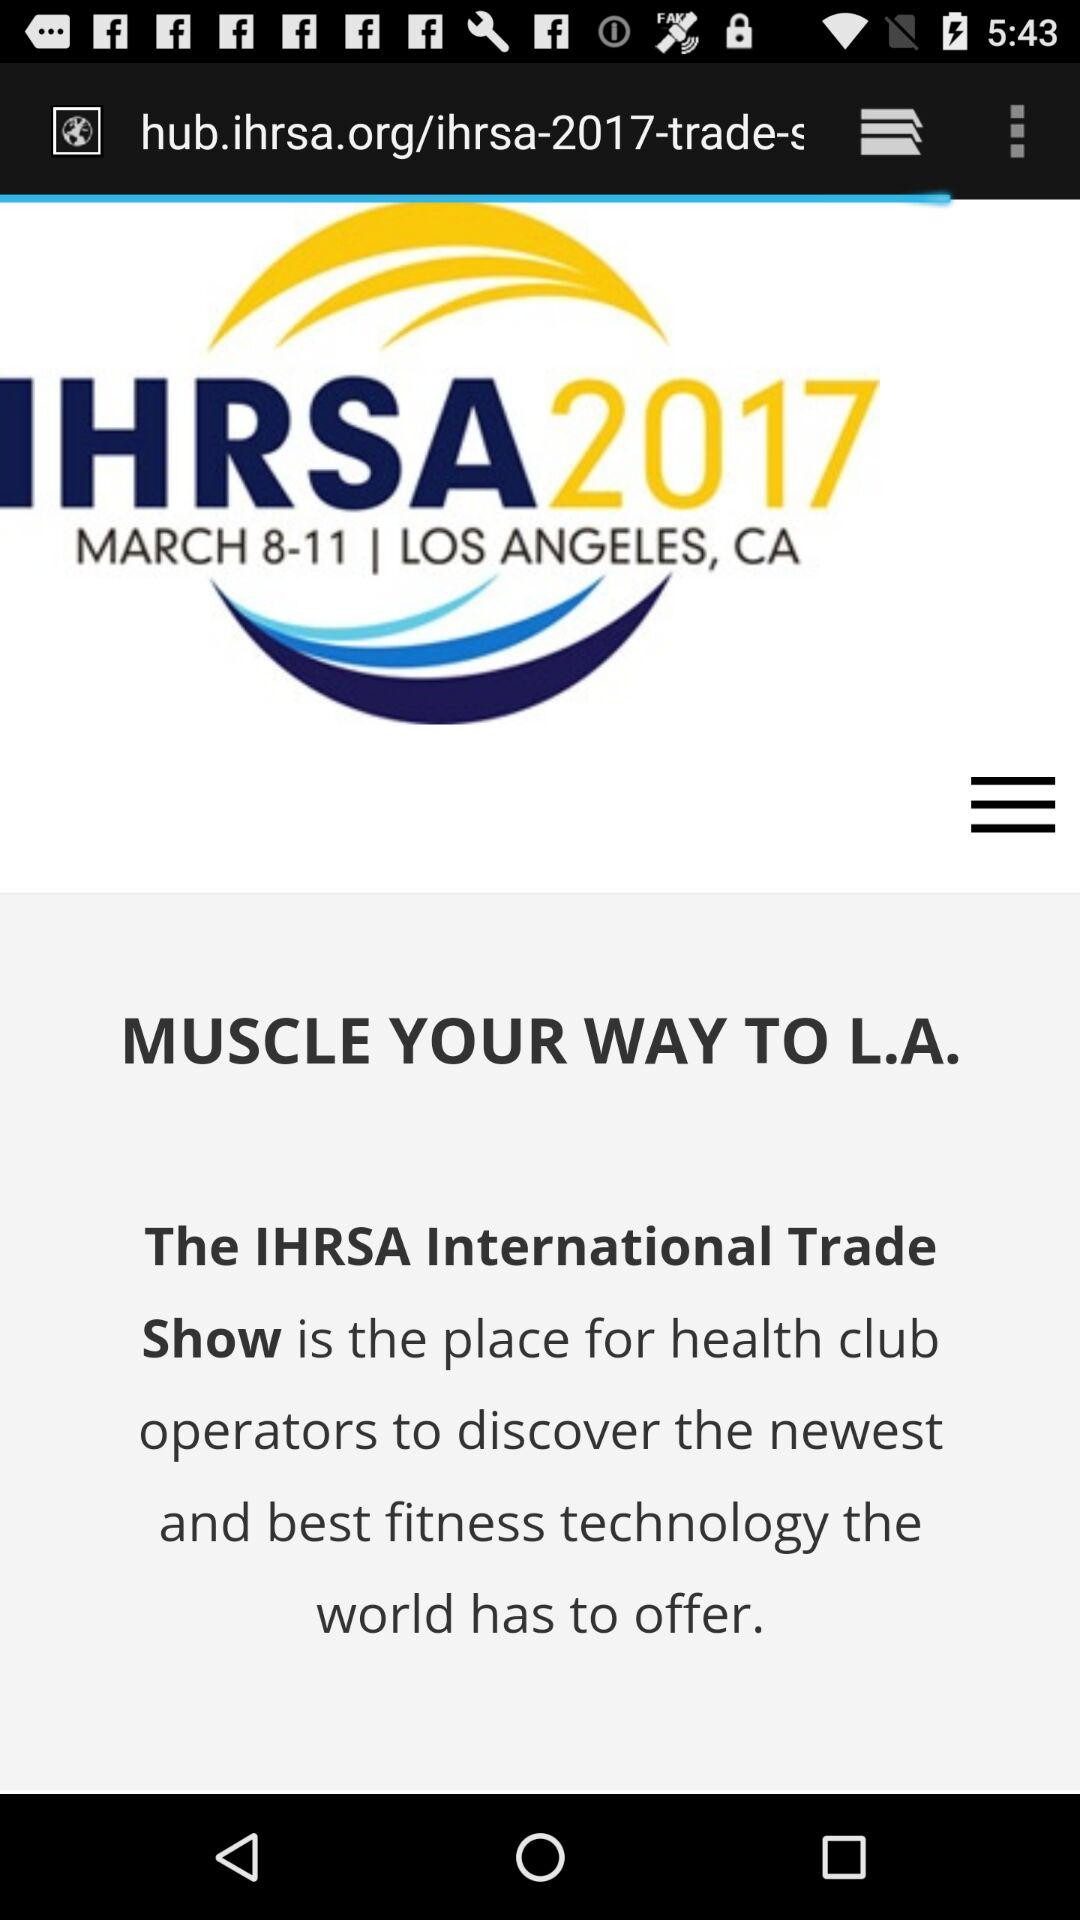From which date until which date will the show be held? The show will be held from March 8 to March 11. 